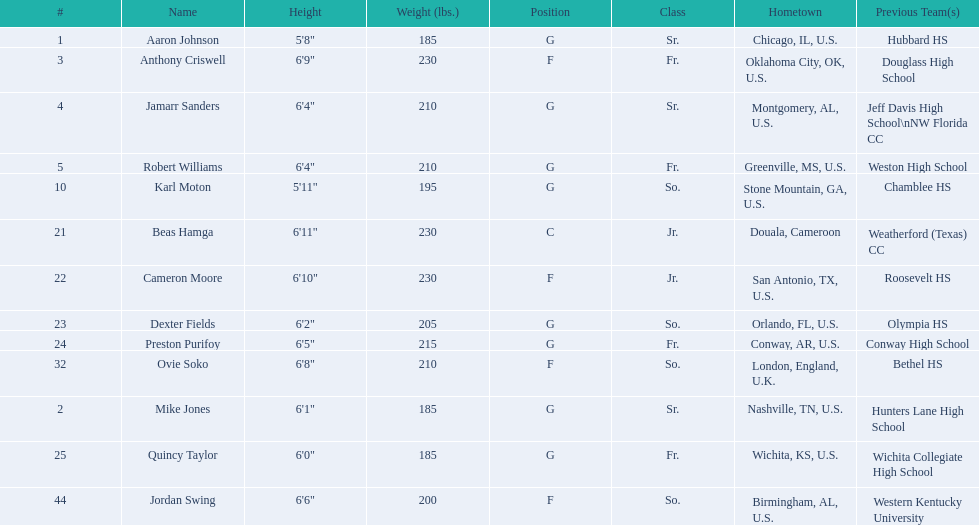Can you provide a list of all the players? Aaron Johnson, Anthony Criswell, Jamarr Sanders, Robert Williams, Karl Moton, Beas Hamga, Cameron Moore, Dexter Fields, Preston Purifoy, Ovie Soko, Mike Jones, Quincy Taylor, Jordan Swing. Which ones are not from the united states? Beas Hamga, Ovie Soko. Excluding soko, who are the other players from outside the u.s.? Beas Hamga. 